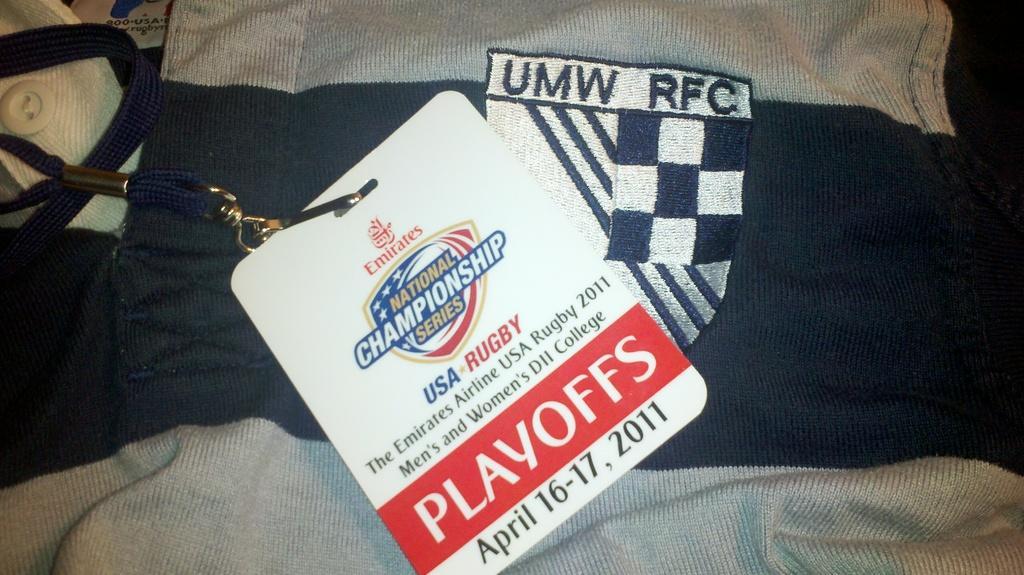Describe this image in one or two sentences. In this picture we can see the clothes, button, tag. 